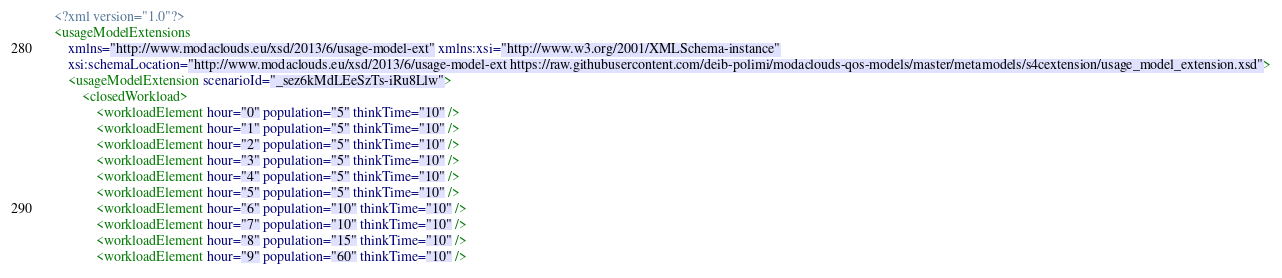<code> <loc_0><loc_0><loc_500><loc_500><_XML_><?xml version="1.0"?>
<usageModelExtensions
	xmlns="http://www.modaclouds.eu/xsd/2013/6/usage-model-ext" xmlns:xsi="http://www.w3.org/2001/XMLSchema-instance"
	xsi:schemaLocation="http://www.modaclouds.eu/xsd/2013/6/usage-model-ext https://raw.githubusercontent.com/deib-polimi/modaclouds-qos-models/master/metamodels/s4cextension/usage_model_extension.xsd">
	<usageModelExtension scenarioId="_sez6kMdLEeSzTs-iRu8Llw">
		<closedWorkload>
			<workloadElement hour="0" population="5" thinkTime="10" />
			<workloadElement hour="1" population="5" thinkTime="10" />
			<workloadElement hour="2" population="5" thinkTime="10" />
			<workloadElement hour="3" population="5" thinkTime="10" />
			<workloadElement hour="4" population="5" thinkTime="10" />
			<workloadElement hour="5" population="5" thinkTime="10" />
			<workloadElement hour="6" population="10" thinkTime="10" />
			<workloadElement hour="7" population="10" thinkTime="10" />
			<workloadElement hour="8" population="15" thinkTime="10" />
			<workloadElement hour="9" population="60" thinkTime="10" /></code> 